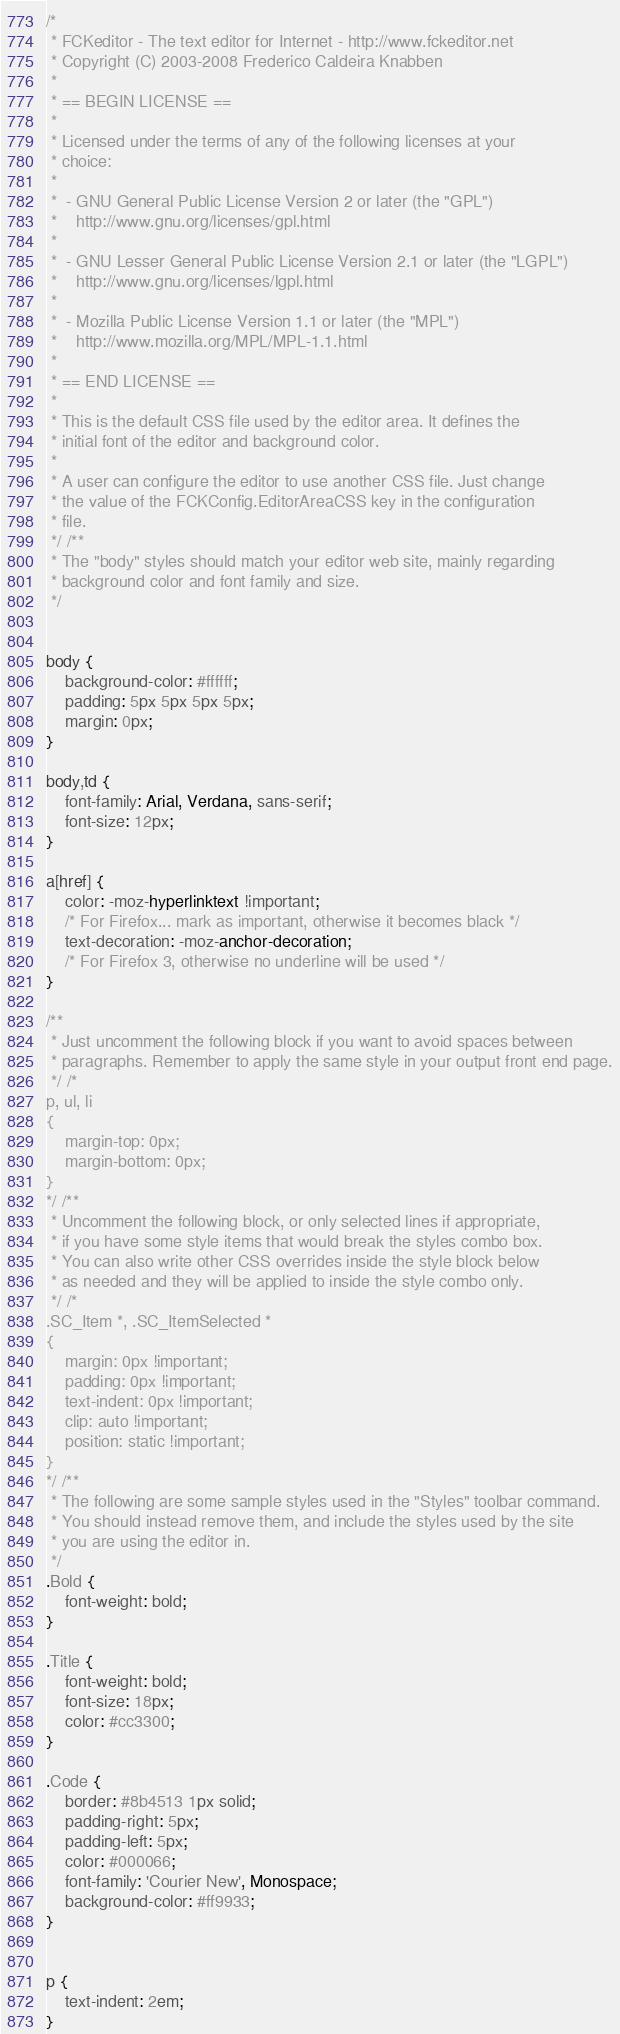<code> <loc_0><loc_0><loc_500><loc_500><_CSS_>/*
 * FCKeditor - The text editor for Internet - http://www.fckeditor.net
 * Copyright (C) 2003-2008 Frederico Caldeira Knabben
 *
 * == BEGIN LICENSE ==
 *
 * Licensed under the terms of any of the following licenses at your
 * choice:
 *
 *  - GNU General Public License Version 2 or later (the "GPL")
 *    http://www.gnu.org/licenses/gpl.html
 *
 *  - GNU Lesser General Public License Version 2.1 or later (the "LGPL")
 *    http://www.gnu.org/licenses/lgpl.html
 *
 *  - Mozilla Public License Version 1.1 or later (the "MPL")
 *    http://www.mozilla.org/MPL/MPL-1.1.html
 *
 * == END LICENSE ==
 *
 * This is the default CSS file used by the editor area. It defines the
 * initial font of the editor and background color.
 *
 * A user can configure the editor to use another CSS file. Just change
 * the value of the FCKConfig.EditorAreaCSS key in the configuration
 * file.
 */ /**
 * The "body" styles should match your editor web site, mainly regarding
 * background color and font family and size.
 */


body {
	background-color: #ffffff;
	padding: 5px 5px 5px 5px;
	margin: 0px;
}

body,td {
	font-family: Arial, Verdana, sans-serif;
	font-size: 12px;
}

a[href] {
	color: -moz-hyperlinktext !important;
	/* For Firefox... mark as important, otherwise it becomes black */
	text-decoration: -moz-anchor-decoration;
	/* For Firefox 3, otherwise no underline will be used */
}

/**
 * Just uncomment the following block if you want to avoid spaces between
 * paragraphs. Remember to apply the same style in your output front end page.
 */ /*
p, ul, li
{
	margin-top: 0px;
	margin-bottom: 0px;
}
*/ /**
 * Uncomment the following block, or only selected lines if appropriate,
 * if you have some style items that would break the styles combo box.
 * You can also write other CSS overrides inside the style block below
 * as needed and they will be applied to inside the style combo only.
 */ /*
.SC_Item *, .SC_ItemSelected *
{
	margin: 0px !important;
	padding: 0px !important;
	text-indent: 0px !important;
	clip: auto !important;
	position: static !important;
}
*/ /**
 * The following are some sample styles used in the "Styles" toolbar command.
 * You should instead remove them, and include the styles used by the site
 * you are using the editor in.
 */
.Bold {
	font-weight: bold;
}

.Title {
	font-weight: bold;
	font-size: 18px;
	color: #cc3300;
}

.Code {
	border: #8b4513 1px solid;
	padding-right: 5px;
	padding-left: 5px;
	color: #000066;
	font-family: 'Courier New', Monospace;
	background-color: #ff9933;
}


p {
	text-indent: 2em;
}</code> 